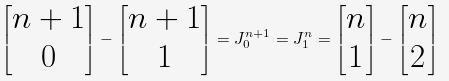<formula> <loc_0><loc_0><loc_500><loc_500>\begin{bmatrix} n + 1 \\ 0 \end{bmatrix} - \begin{bmatrix} n + 1 \\ 1 \end{bmatrix} = J _ { 0 } ^ { n + 1 } = J _ { 1 } ^ { n } = \begin{bmatrix} n \\ 1 \end{bmatrix} - \begin{bmatrix} n \\ 2 \end{bmatrix}</formula> 